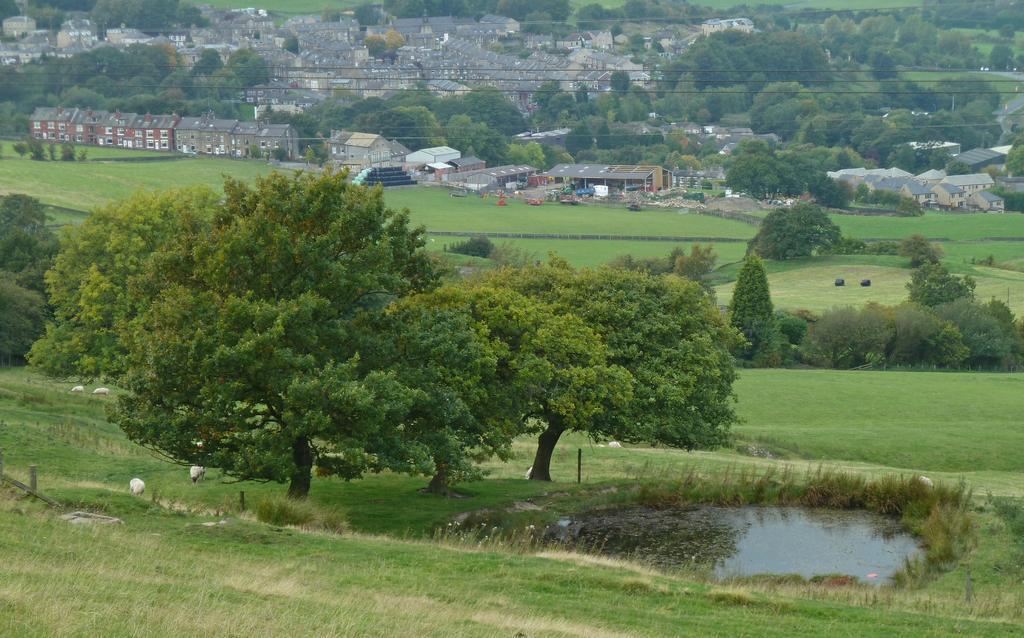In one or two sentences, can you explain what this image depicts? Here in this picture in the front we can see the ground is fully covered with grass and on the right side we can see water at some place and we can also see plants and trees present and in the far we can see buildings and houses present. 